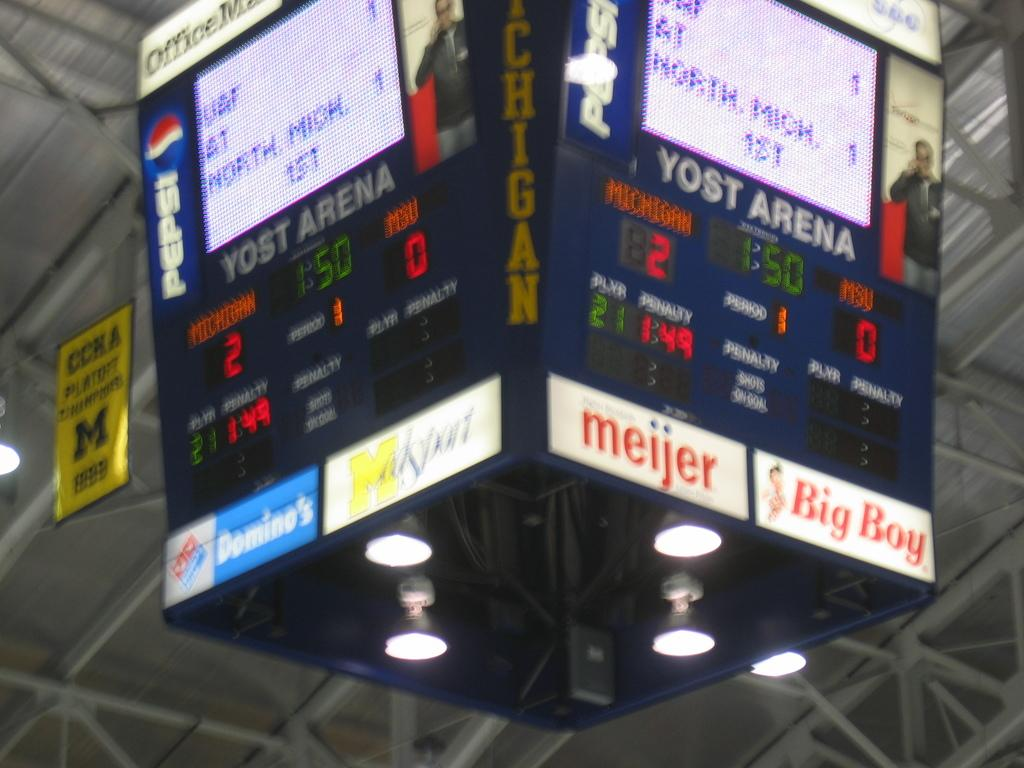<image>
Describe the image concisely. Scoreboard inside Yost Arena with Dominos as one of the sponsors. 